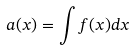<formula> <loc_0><loc_0><loc_500><loc_500>a ( x ) = \int f ( x ) d x</formula> 